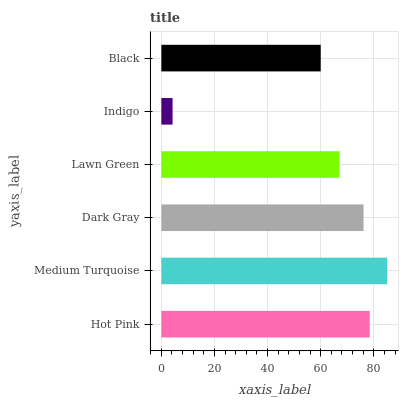Is Indigo the minimum?
Answer yes or no. Yes. Is Medium Turquoise the maximum?
Answer yes or no. Yes. Is Dark Gray the minimum?
Answer yes or no. No. Is Dark Gray the maximum?
Answer yes or no. No. Is Medium Turquoise greater than Dark Gray?
Answer yes or no. Yes. Is Dark Gray less than Medium Turquoise?
Answer yes or no. Yes. Is Dark Gray greater than Medium Turquoise?
Answer yes or no. No. Is Medium Turquoise less than Dark Gray?
Answer yes or no. No. Is Dark Gray the high median?
Answer yes or no. Yes. Is Lawn Green the low median?
Answer yes or no. Yes. Is Indigo the high median?
Answer yes or no. No. Is Hot Pink the low median?
Answer yes or no. No. 